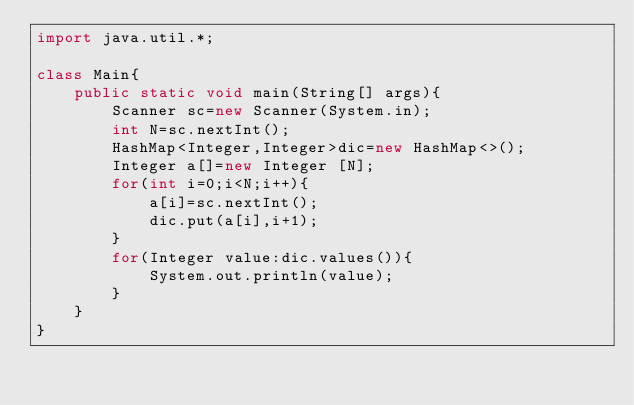Convert code to text. <code><loc_0><loc_0><loc_500><loc_500><_Java_>import java.util.*;

class Main{
    public static void main(String[] args){
        Scanner sc=new Scanner(System.in);
        int N=sc.nextInt();
        HashMap<Integer,Integer>dic=new HashMap<>();
        Integer a[]=new Integer [N];
        for(int i=0;i<N;i++){
            a[i]=sc.nextInt();
            dic.put(a[i],i+1);
        }
        for(Integer value:dic.values()){
            System.out.println(value);
        }
    }
}</code> 